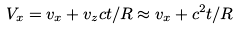<formula> <loc_0><loc_0><loc_500><loc_500>V _ { x } = v _ { x } + v _ { z } c t / R \approx v _ { x } + c ^ { 2 } t / R</formula> 